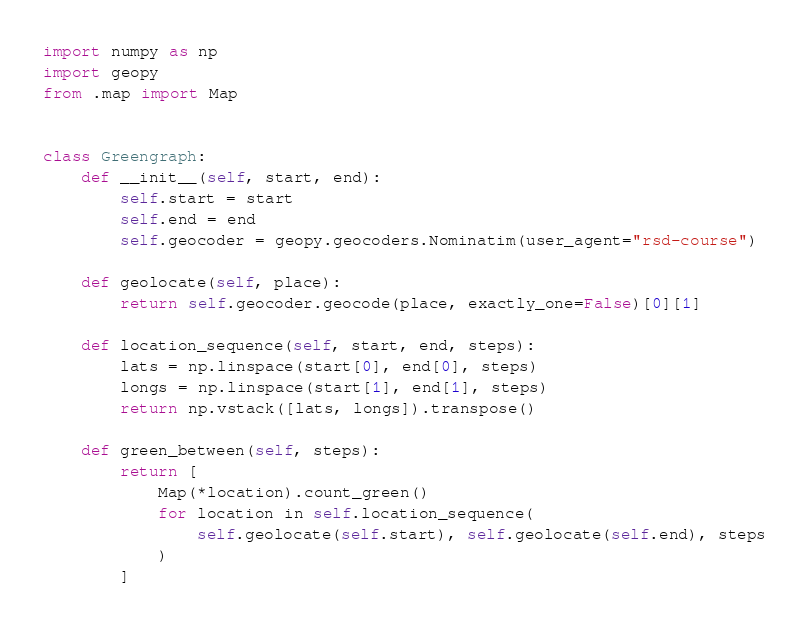Convert code to text. <code><loc_0><loc_0><loc_500><loc_500><_Python_>import numpy as np
import geopy
from .map import Map


class Greengraph:
    def __init__(self, start, end):
        self.start = start
        self.end = end
        self.geocoder = geopy.geocoders.Nominatim(user_agent="rsd-course")

    def geolocate(self, place):
        return self.geocoder.geocode(place, exactly_one=False)[0][1]

    def location_sequence(self, start, end, steps):
        lats = np.linspace(start[0], end[0], steps)
        longs = np.linspace(start[1], end[1], steps)
        return np.vstack([lats, longs]).transpose()

    def green_between(self, steps):
        return [
            Map(*location).count_green()
            for location in self.location_sequence(
                self.geolocate(self.start), self.geolocate(self.end), steps
            )
        ]
</code> 